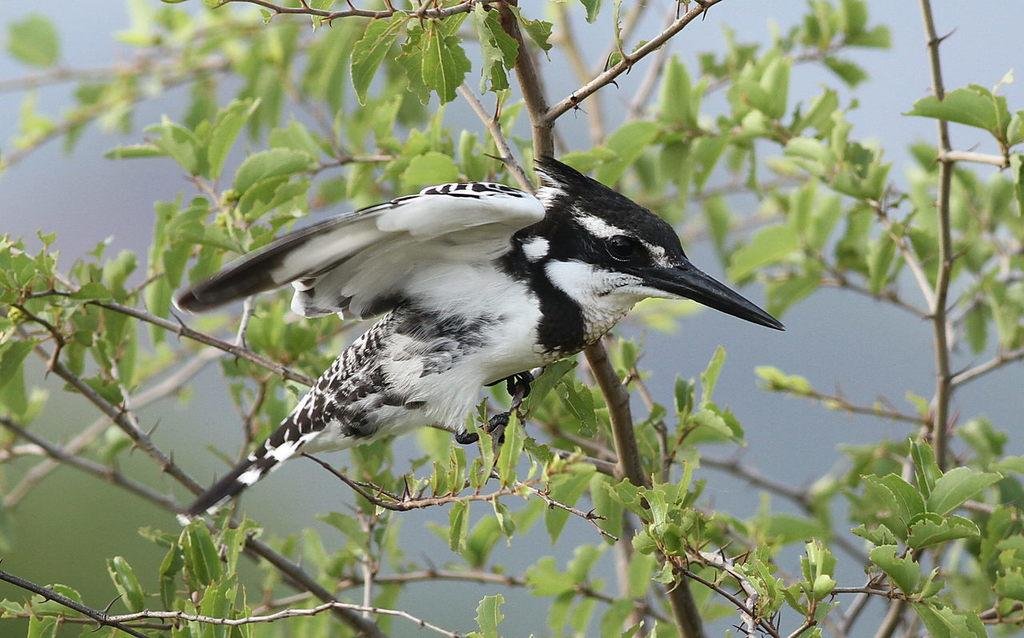What type of animal can be seen in the image? There is a bird in the image. Can you describe the color pattern of the bird? The bird is white and black in color. Where is the bird located in the image? The bird is sitting on a plant stem. What type of vegetation can be seen in the image? There are leaves visible in the image. How would you describe the background of the image? The background of the image is blurred. What type of meat is being served with a spoon in the image? There is no meat or spoon present in the image; it features a bird sitting on a plant stem with leaves in the background. What type of coil can be seen in the image? There is no coil present in the image. 